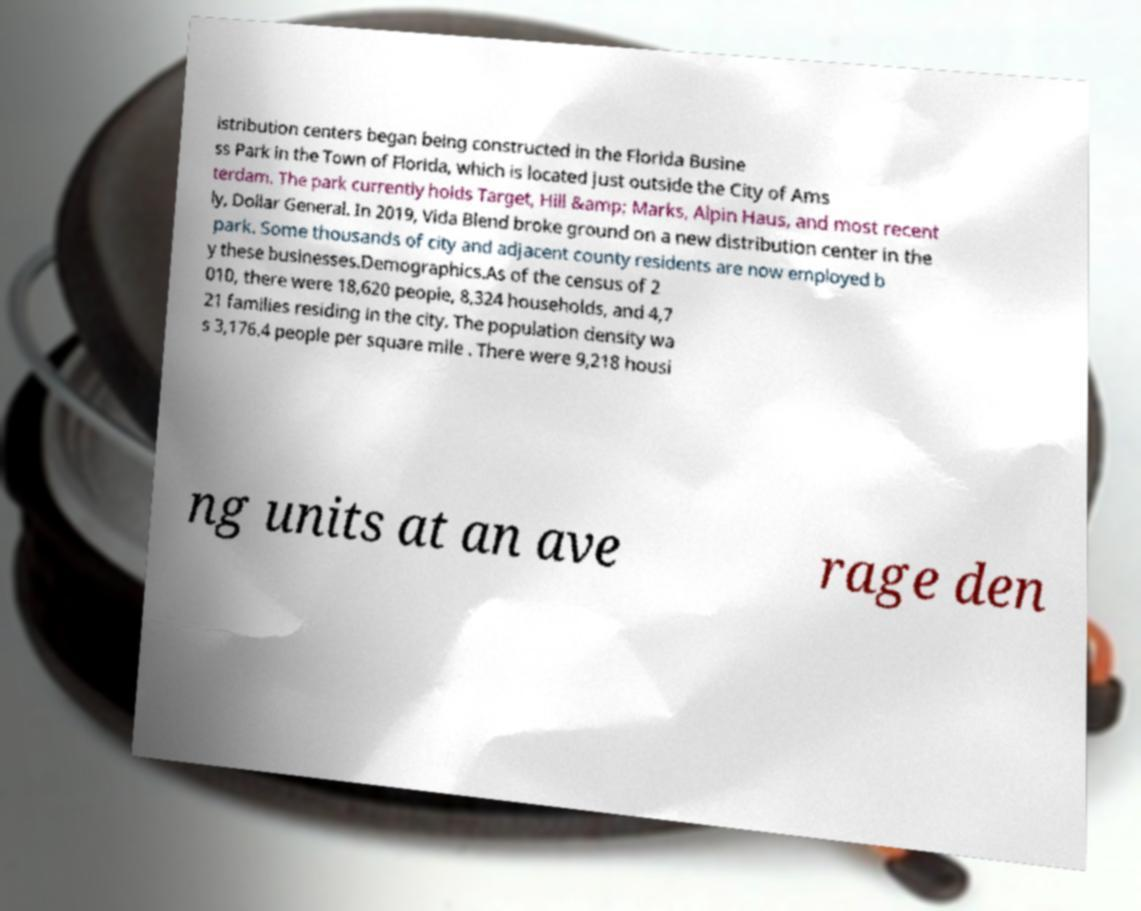Could you extract and type out the text from this image? istribution centers began being constructed in the Florida Busine ss Park in the Town of Florida, which is located just outside the City of Ams terdam. The park currently holds Target, Hill &amp; Marks, Alpin Haus, and most recent ly, Dollar General. In 2019, Vida Blend broke ground on a new distribution center in the park. Some thousands of city and adjacent county residents are now employed b y these businesses.Demographics.As of the census of 2 010, there were 18,620 people, 8,324 households, and 4,7 21 families residing in the city. The population density wa s 3,176.4 people per square mile . There were 9,218 housi ng units at an ave rage den 